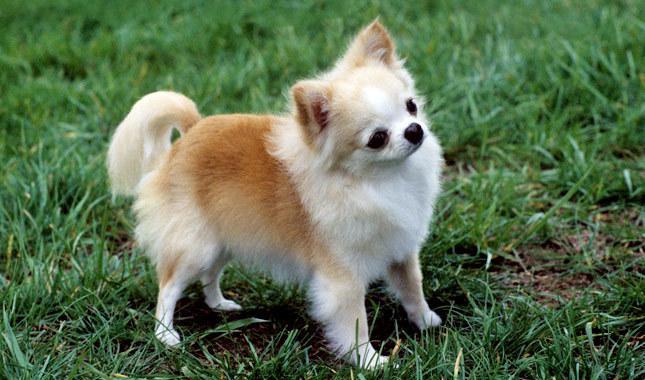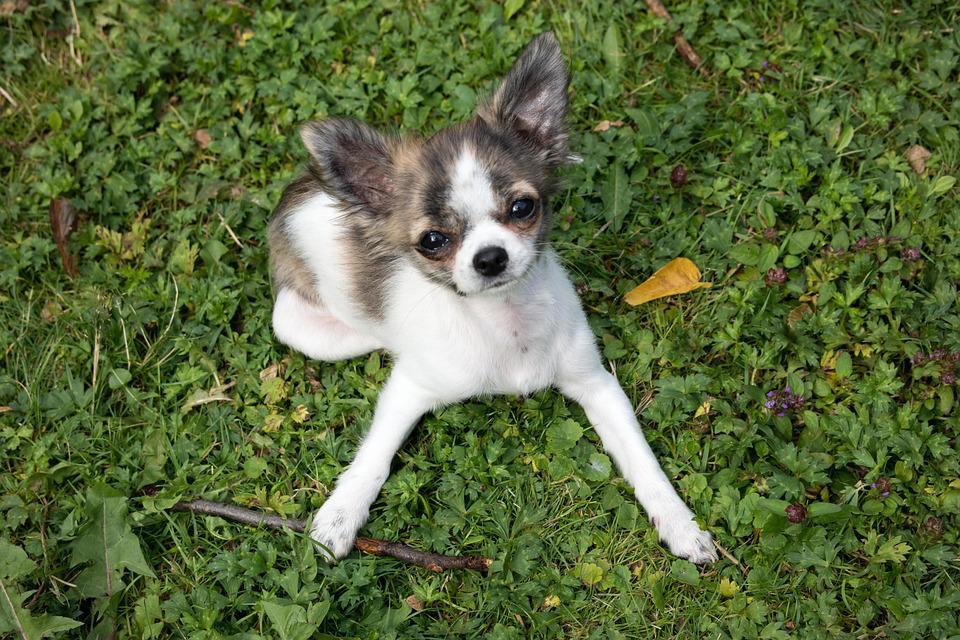The first image is the image on the left, the second image is the image on the right. Analyze the images presented: Is the assertion "there are two dogs whose full body is shown on the image" valid? Answer yes or no. Yes. 